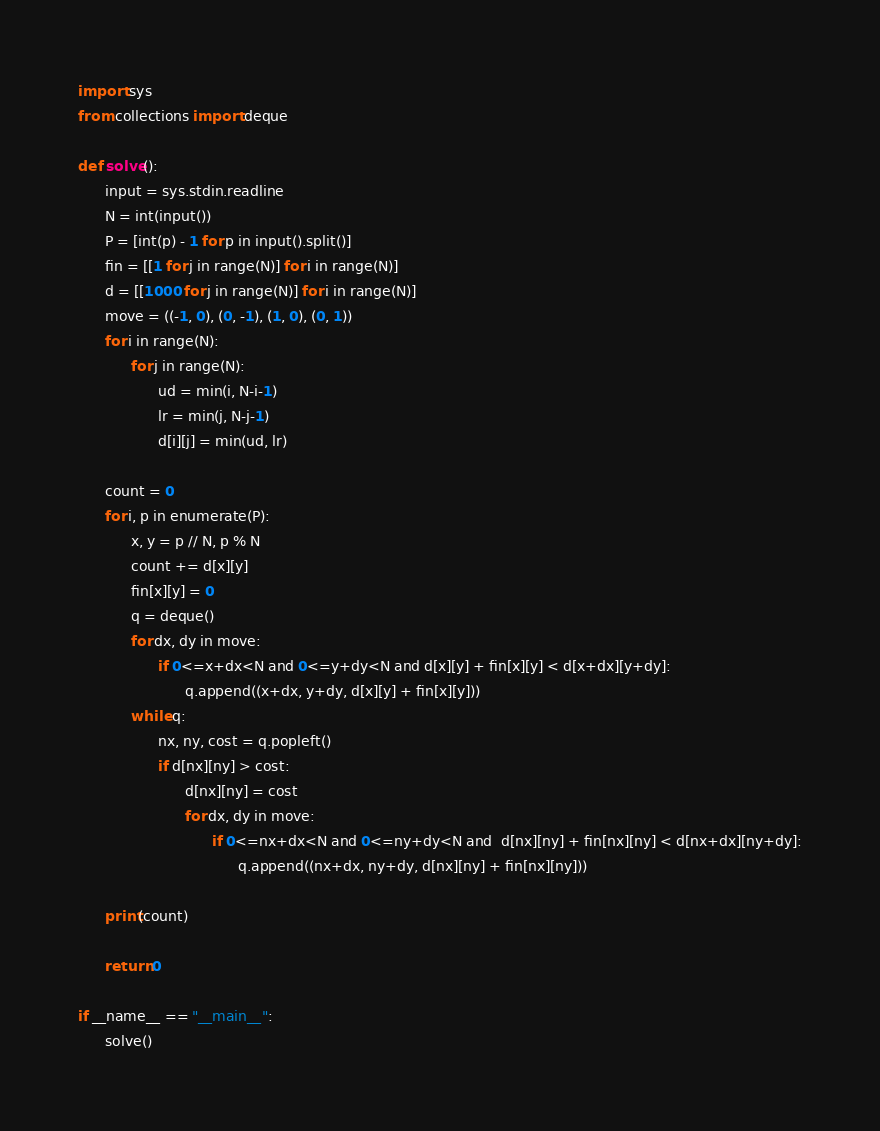Convert code to text. <code><loc_0><loc_0><loc_500><loc_500><_Cython_>import sys
from collections import deque

def solve():
      input = sys.stdin.readline
      N = int(input())
      P = [int(p) - 1 for p in input().split()]
      fin = [[1 for j in range(N)] for i in range(N)]
      d = [[1000 for j in range(N)] for i in range(N)]      
      move = ((-1, 0), (0, -1), (1, 0), (0, 1))
      for i in range(N):
            for j in range(N):
                  ud = min(i, N-i-1)
                  lr = min(j, N-j-1)
                  d[i][j] = min(ud, lr)
  
      count = 0
      for i, p in enumerate(P):
            x, y = p // N, p % N
            count += d[x][y]
            fin[x][y] = 0
            q = deque()
            for dx, dy in move:
                  if 0<=x+dx<N and 0<=y+dy<N and d[x][y] + fin[x][y] < d[x+dx][y+dy]:
                        q.append((x+dx, y+dy, d[x][y] + fin[x][y]))
            while q:
                  nx, ny, cost = q.popleft()
                  if d[nx][ny] > cost:
                        d[nx][ny] = cost
                        for dx, dy in move:
                              if 0<=nx+dx<N and 0<=ny+dy<N and  d[nx][ny] + fin[nx][ny] < d[nx+dx][ny+dy]:
                                    q.append((nx+dx, ny+dy, d[nx][ny] + fin[nx][ny]))

      print(count)
            
      return 0

if __name__ == "__main__":
      solve()</code> 